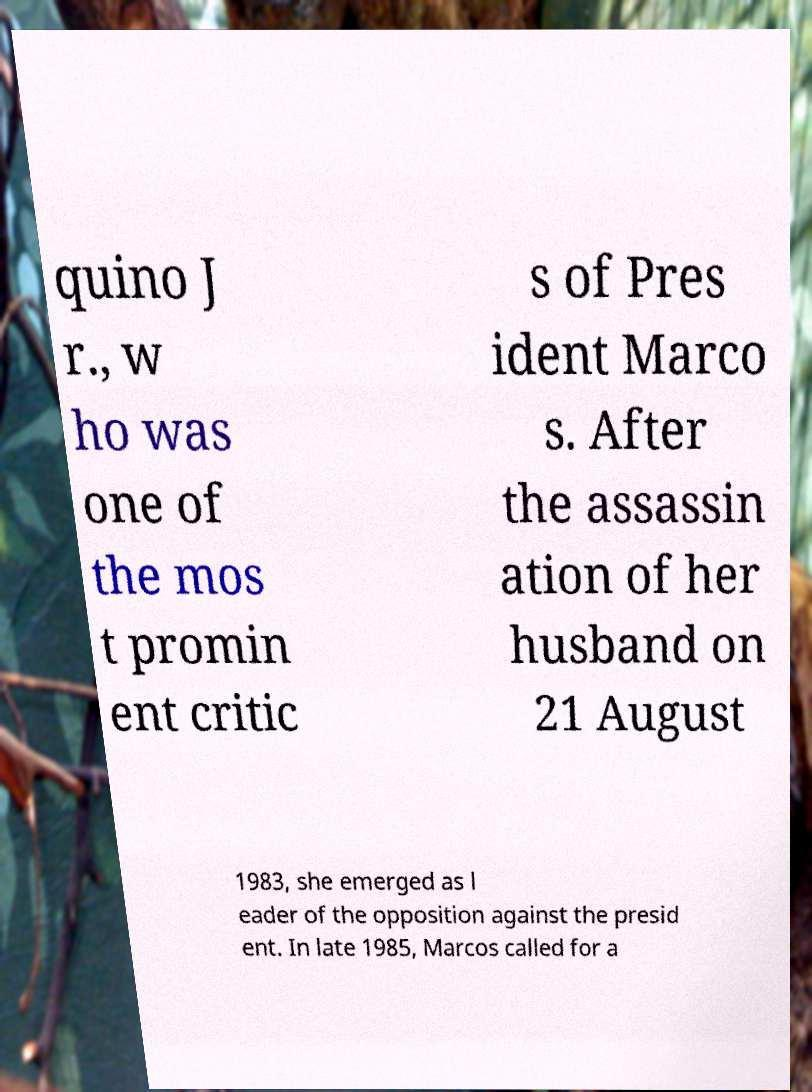What messages or text are displayed in this image? I need them in a readable, typed format. quino J r., w ho was one of the mos t promin ent critic s of Pres ident Marco s. After the assassin ation of her husband on 21 August 1983, she emerged as l eader of the opposition against the presid ent. In late 1985, Marcos called for a 